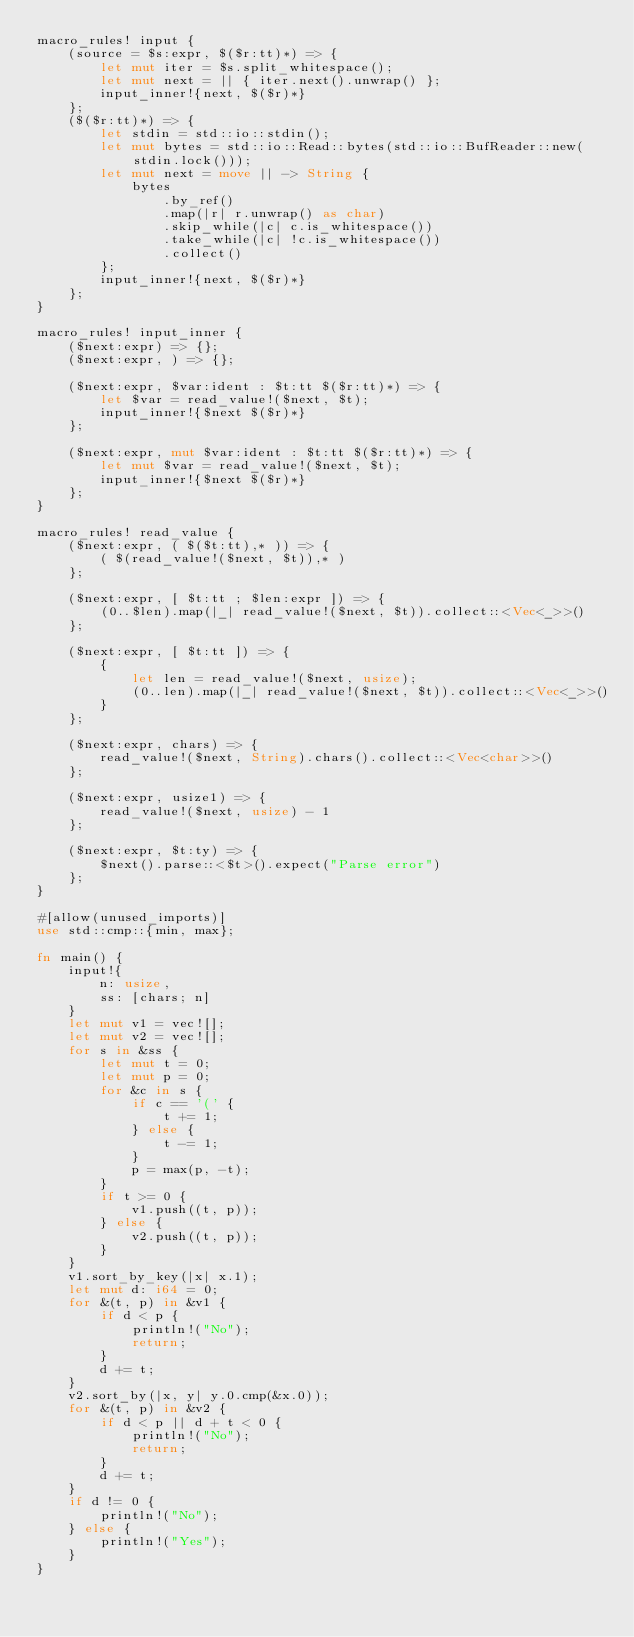Convert code to text. <code><loc_0><loc_0><loc_500><loc_500><_Rust_>macro_rules! input {
    (source = $s:expr, $($r:tt)*) => {
        let mut iter = $s.split_whitespace();
        let mut next = || { iter.next().unwrap() };
        input_inner!{next, $($r)*}
    };
    ($($r:tt)*) => {
        let stdin = std::io::stdin();
        let mut bytes = std::io::Read::bytes(std::io::BufReader::new(stdin.lock()));
        let mut next = move || -> String {
            bytes
                .by_ref()
                .map(|r| r.unwrap() as char)
                .skip_while(|c| c.is_whitespace())
                .take_while(|c| !c.is_whitespace())
                .collect()
        };
        input_inner!{next, $($r)*}
    };
}

macro_rules! input_inner {
    ($next:expr) => {};
    ($next:expr, ) => {};

    ($next:expr, $var:ident : $t:tt $($r:tt)*) => {
        let $var = read_value!($next, $t);
        input_inner!{$next $($r)*}
    };

    ($next:expr, mut $var:ident : $t:tt $($r:tt)*) => {
        let mut $var = read_value!($next, $t);
        input_inner!{$next $($r)*}
    };
}

macro_rules! read_value {
    ($next:expr, ( $($t:tt),* )) => {
        ( $(read_value!($next, $t)),* )
    };

    ($next:expr, [ $t:tt ; $len:expr ]) => {
        (0..$len).map(|_| read_value!($next, $t)).collect::<Vec<_>>()
    };

    ($next:expr, [ $t:tt ]) => {
        {
            let len = read_value!($next, usize);
            (0..len).map(|_| read_value!($next, $t)).collect::<Vec<_>>()
        }
    };

    ($next:expr, chars) => {
        read_value!($next, String).chars().collect::<Vec<char>>()
    };

    ($next:expr, usize1) => {
        read_value!($next, usize) - 1
    };

    ($next:expr, $t:ty) => {
        $next().parse::<$t>().expect("Parse error")
    };
}

#[allow(unused_imports)]
use std::cmp::{min, max};

fn main() {
    input!{
        n: usize,
        ss: [chars; n]
    }
    let mut v1 = vec![];
    let mut v2 = vec![];
    for s in &ss {
        let mut t = 0;
        let mut p = 0;
        for &c in s {
            if c == '(' {
                t += 1;
            } else {
                t -= 1;
            }
            p = max(p, -t);
        }
        if t >= 0 {
            v1.push((t, p));
        } else {
            v2.push((t, p));
        }
    }
    v1.sort_by_key(|x| x.1);
    let mut d: i64 = 0;
    for &(t, p) in &v1 {
        if d < p {
            println!("No");
            return;
        }
        d += t;
    }
    v2.sort_by(|x, y| y.0.cmp(&x.0));
    for &(t, p) in &v2 {
        if d < p || d + t < 0 {
            println!("No");
            return;
        }
        d += t;
    }
    if d != 0 {
        println!("No");
    } else {
        println!("Yes");
    }
}
</code> 